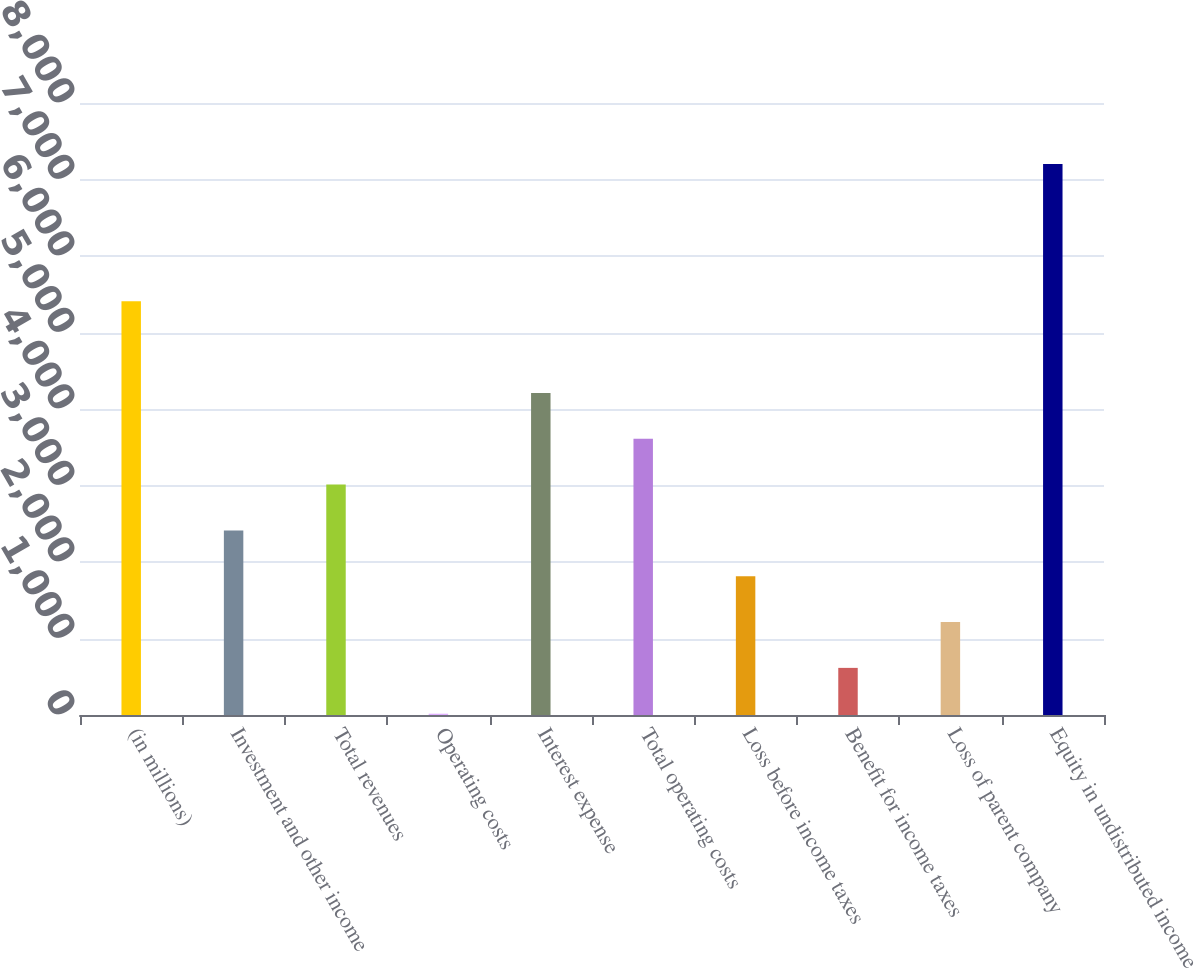Convert chart. <chart><loc_0><loc_0><loc_500><loc_500><bar_chart><fcel>(in millions)<fcel>Investment and other income<fcel>Total revenues<fcel>Operating costs<fcel>Interest expense<fcel>Total operating costs<fcel>Loss before income taxes<fcel>Benefit for income taxes<fcel>Loss of parent company<fcel>Equity in undistributed income<nl><fcel>5407.1<fcel>2412.6<fcel>3011.5<fcel>17<fcel>4209.3<fcel>3610.4<fcel>1813.7<fcel>615.9<fcel>1214.8<fcel>7203.8<nl></chart> 